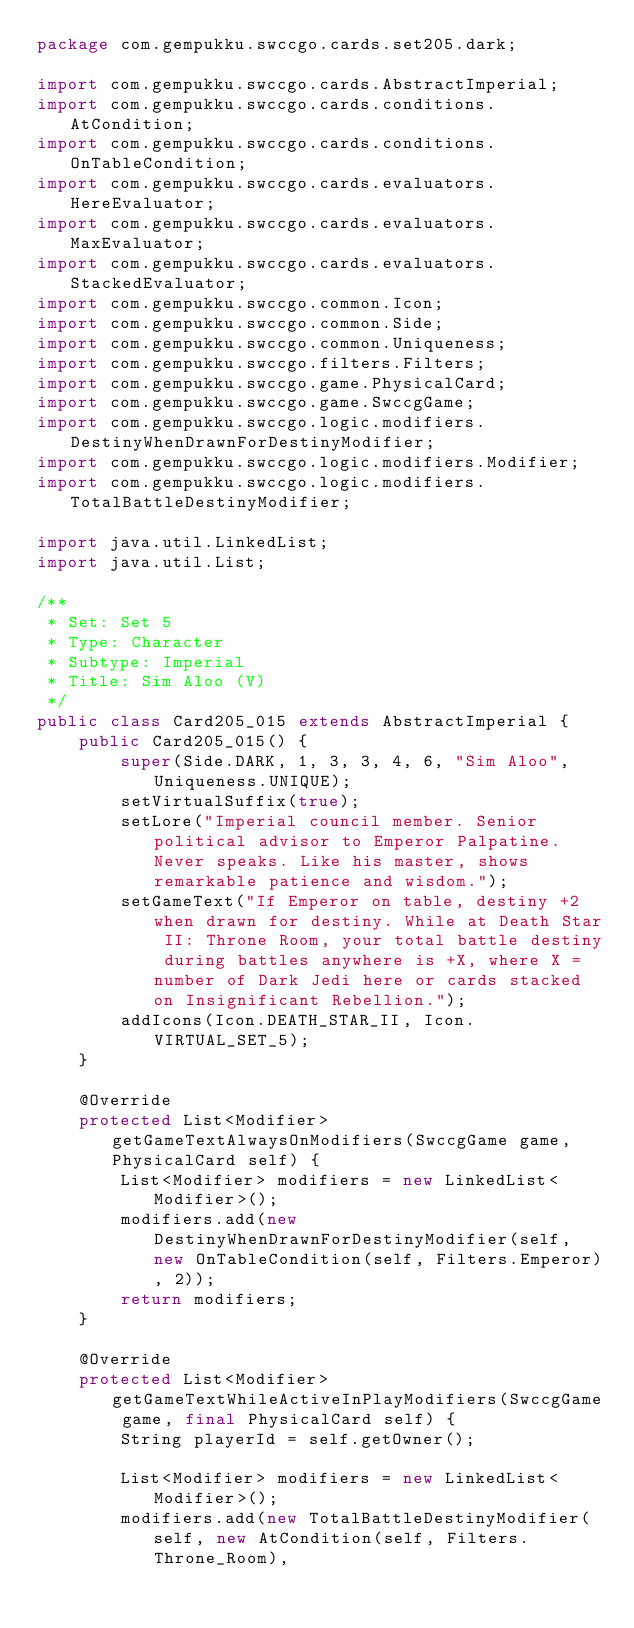Convert code to text. <code><loc_0><loc_0><loc_500><loc_500><_Java_>package com.gempukku.swccgo.cards.set205.dark;

import com.gempukku.swccgo.cards.AbstractImperial;
import com.gempukku.swccgo.cards.conditions.AtCondition;
import com.gempukku.swccgo.cards.conditions.OnTableCondition;
import com.gempukku.swccgo.cards.evaluators.HereEvaluator;
import com.gempukku.swccgo.cards.evaluators.MaxEvaluator;
import com.gempukku.swccgo.cards.evaluators.StackedEvaluator;
import com.gempukku.swccgo.common.Icon;
import com.gempukku.swccgo.common.Side;
import com.gempukku.swccgo.common.Uniqueness;
import com.gempukku.swccgo.filters.Filters;
import com.gempukku.swccgo.game.PhysicalCard;
import com.gempukku.swccgo.game.SwccgGame;
import com.gempukku.swccgo.logic.modifiers.DestinyWhenDrawnForDestinyModifier;
import com.gempukku.swccgo.logic.modifiers.Modifier;
import com.gempukku.swccgo.logic.modifiers.TotalBattleDestinyModifier;

import java.util.LinkedList;
import java.util.List;

/**
 * Set: Set 5
 * Type: Character
 * Subtype: Imperial
 * Title: Sim Aloo (V)
 */
public class Card205_015 extends AbstractImperial {
    public Card205_015() {
        super(Side.DARK, 1, 3, 3, 4, 6, "Sim Aloo", Uniqueness.UNIQUE);
        setVirtualSuffix(true);
        setLore("Imperial council member. Senior political advisor to Emperor Palpatine. Never speaks. Like his master, shows remarkable patience and wisdom.");
        setGameText("If Emperor on table, destiny +2 when drawn for destiny. While at Death Star II: Throne Room, your total battle destiny during battles anywhere is +X, where X = number of Dark Jedi here or cards stacked on Insignificant Rebellion.");
        addIcons(Icon.DEATH_STAR_II, Icon.VIRTUAL_SET_5);
    }

    @Override
    protected List<Modifier> getGameTextAlwaysOnModifiers(SwccgGame game, PhysicalCard self) {
        List<Modifier> modifiers = new LinkedList<Modifier>();
        modifiers.add(new DestinyWhenDrawnForDestinyModifier(self, new OnTableCondition(self, Filters.Emperor), 2));
        return modifiers;
    }

    @Override
    protected List<Modifier> getGameTextWhileActiveInPlayModifiers(SwccgGame game, final PhysicalCard self) {
        String playerId = self.getOwner();

        List<Modifier> modifiers = new LinkedList<Modifier>();
        modifiers.add(new TotalBattleDestinyModifier(self, new AtCondition(self, Filters.Throne_Room),</code> 